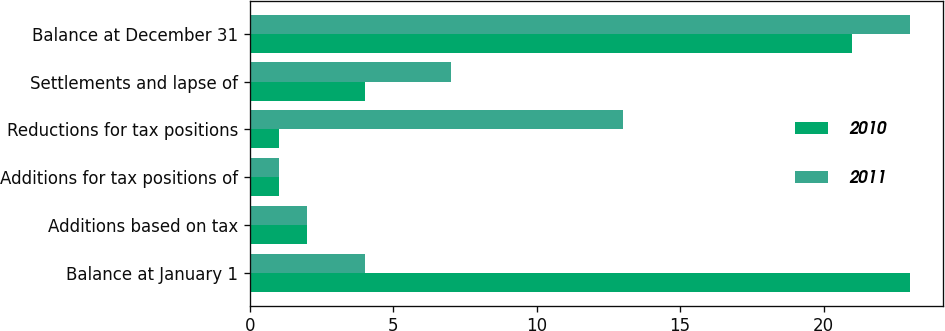Convert chart. <chart><loc_0><loc_0><loc_500><loc_500><stacked_bar_chart><ecel><fcel>Balance at January 1<fcel>Additions based on tax<fcel>Additions for tax positions of<fcel>Reductions for tax positions<fcel>Settlements and lapse of<fcel>Balance at December 31<nl><fcel>2010<fcel>23<fcel>2<fcel>1<fcel>1<fcel>4<fcel>21<nl><fcel>2011<fcel>4<fcel>2<fcel>1<fcel>13<fcel>7<fcel>23<nl></chart> 